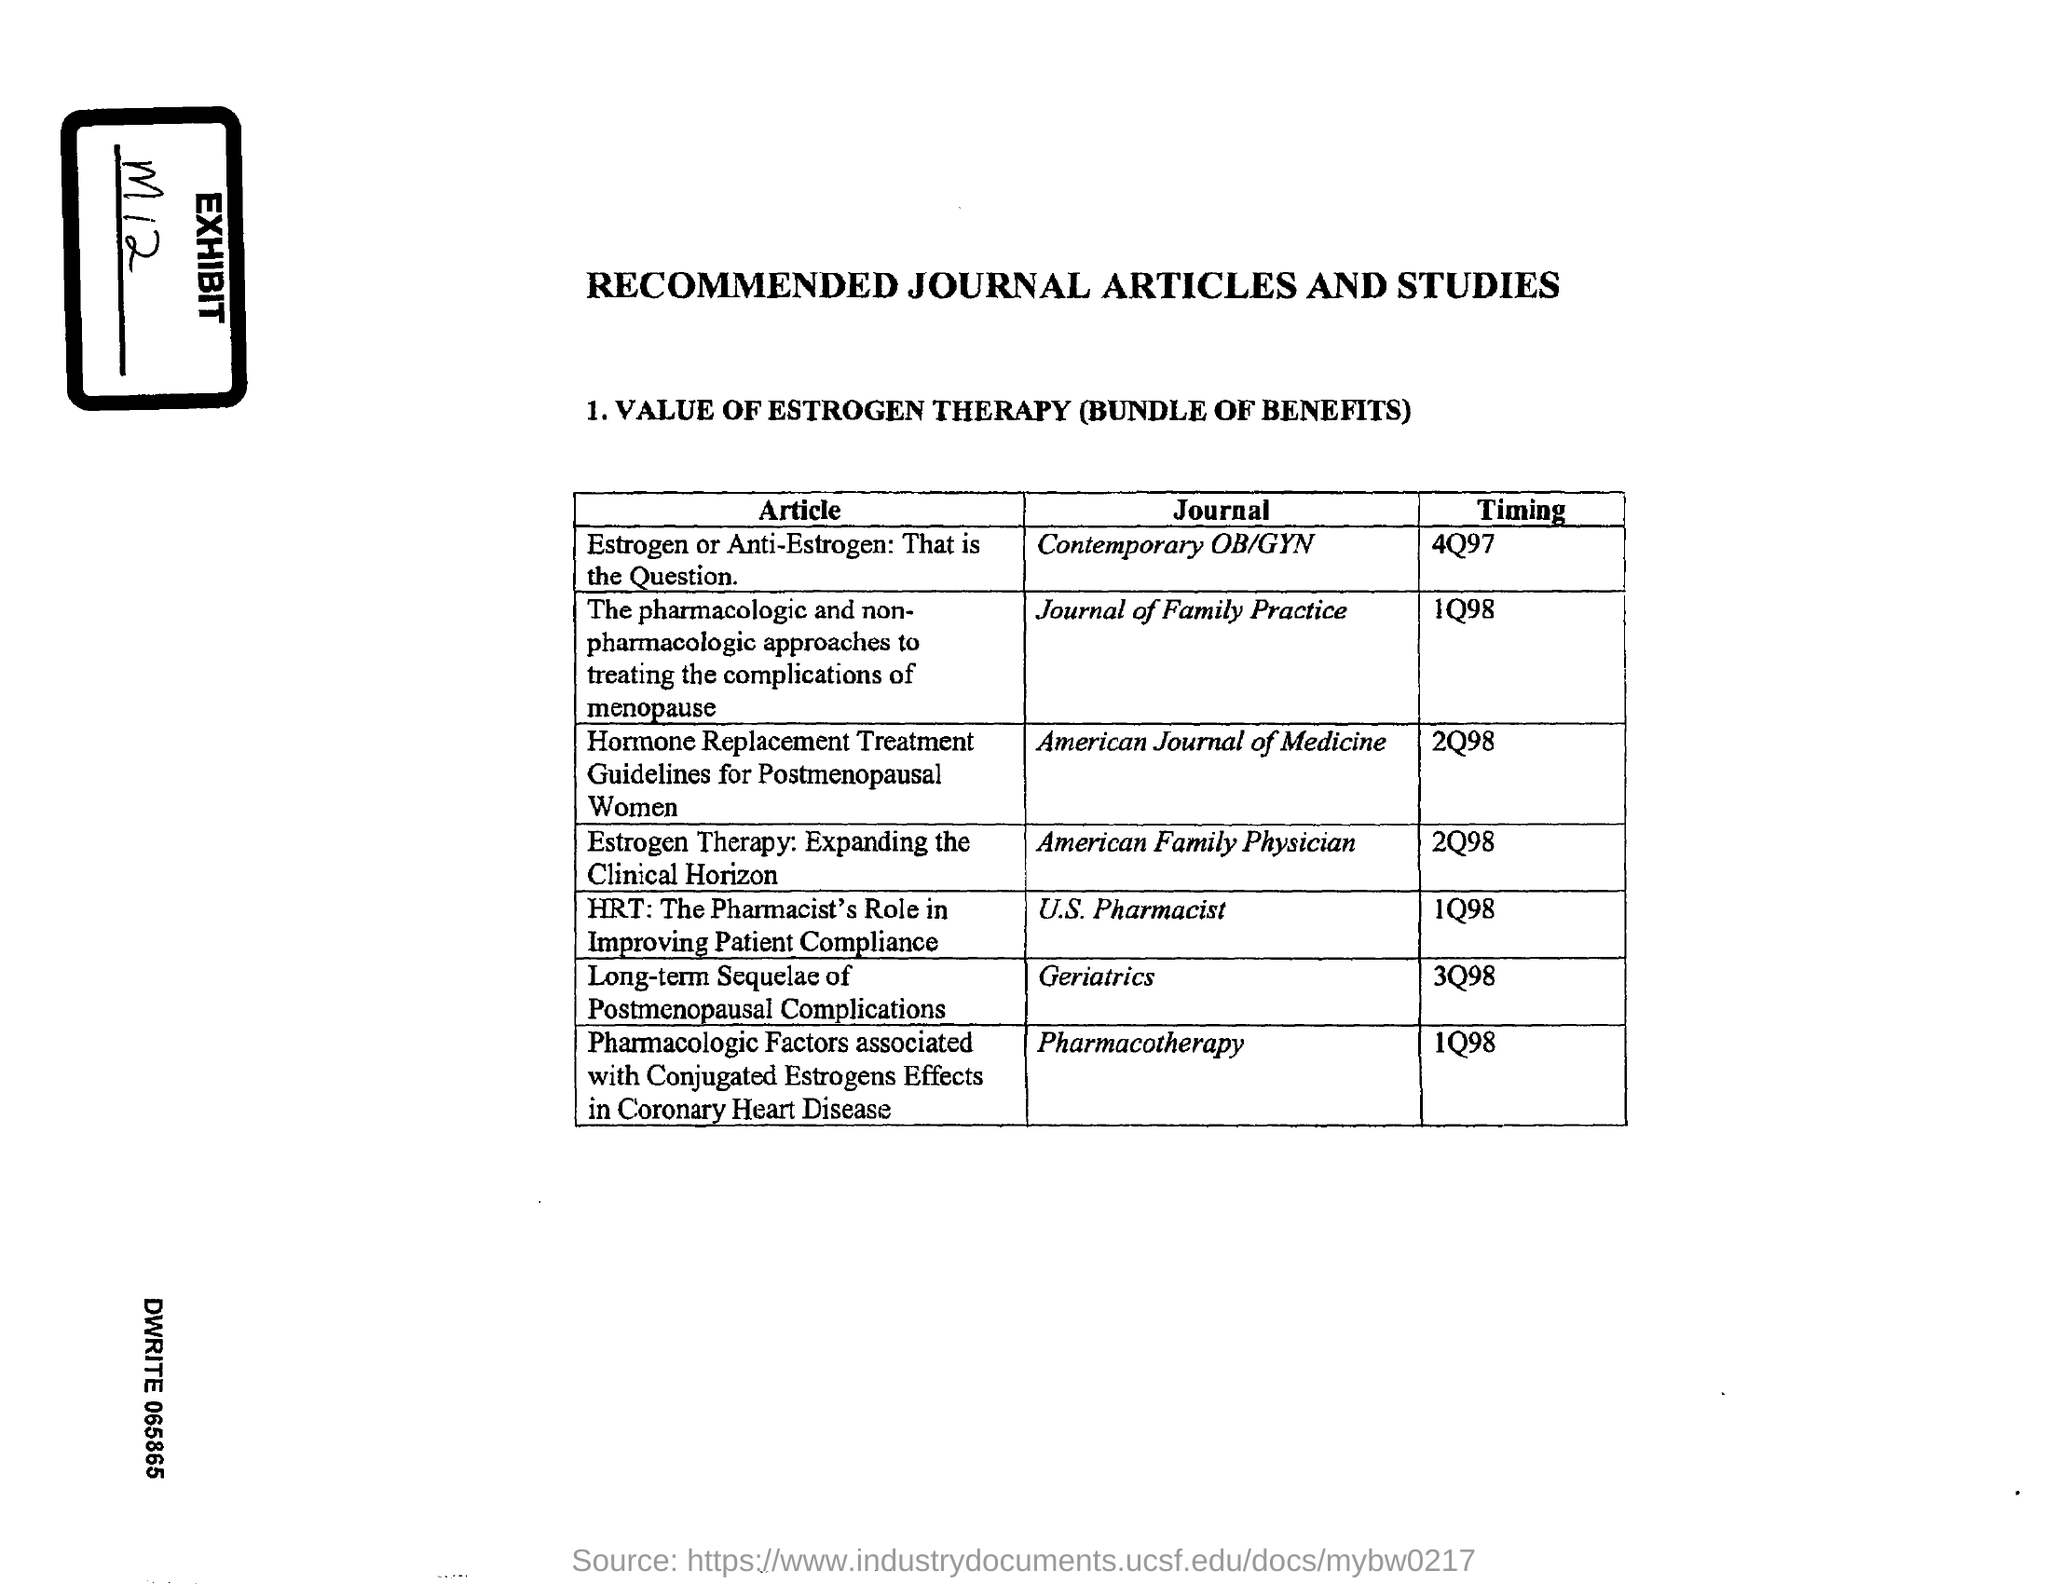Outline some significant characteristics in this image. The article titled 'Estrogen Therapy: Expanding the Clinical Horizon' was published in the journal American Family Physician. The timing mentioned in the article titled "Estrogen or Anti-Estrogen: That is the Question" is 4q97. The exhibit number mentioned in the document is m12.. The article titled 'Estrogen or Anti-Estrogen: That is the Question' was published in the 'Contemporary OB/GYN' journal. The timing mentioned in the article titled "Estrogen Therapy: Expanding the Clinical Horizon" is 2Q98. 